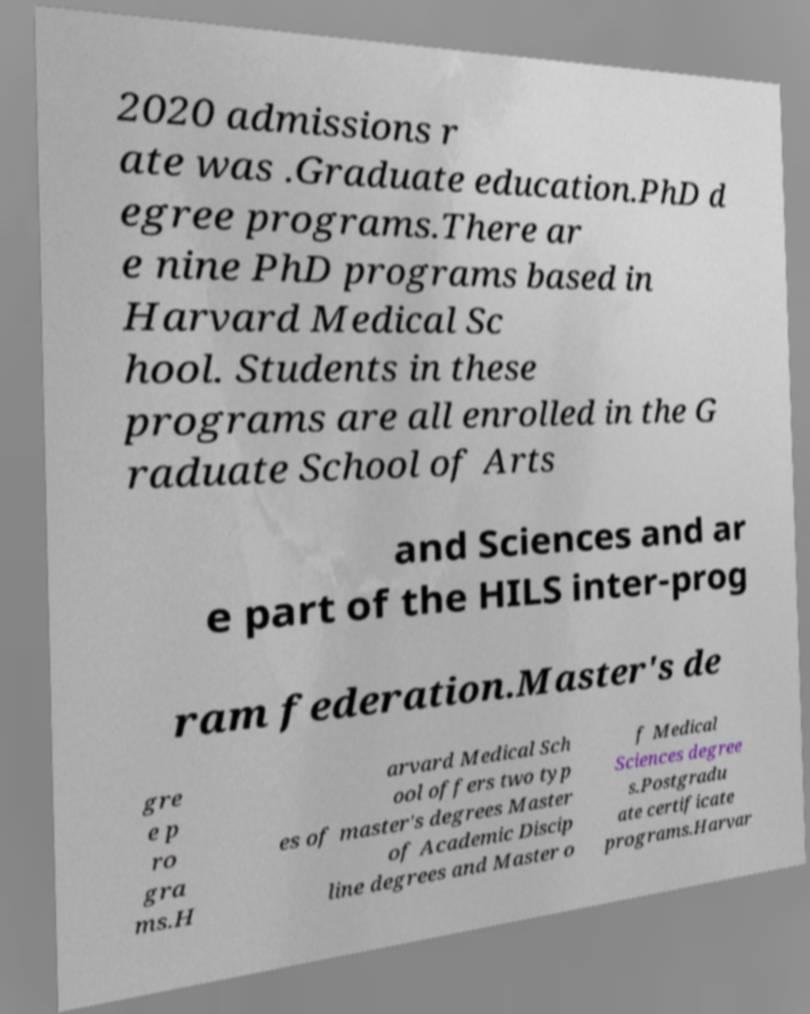I need the written content from this picture converted into text. Can you do that? 2020 admissions r ate was .Graduate education.PhD d egree programs.There ar e nine PhD programs based in Harvard Medical Sc hool. Students in these programs are all enrolled in the G raduate School of Arts and Sciences and ar e part of the HILS inter-prog ram federation.Master's de gre e p ro gra ms.H arvard Medical Sch ool offers two typ es of master's degrees Master of Academic Discip line degrees and Master o f Medical Sciences degree s.Postgradu ate certificate programs.Harvar 